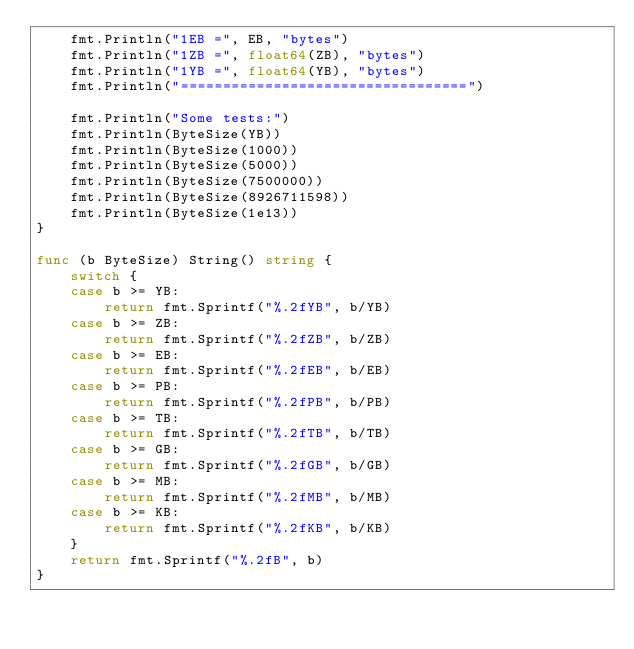<code> <loc_0><loc_0><loc_500><loc_500><_Go_>	fmt.Println("1EB =", EB, "bytes")
	fmt.Println("1ZB =", float64(ZB), "bytes")
	fmt.Println("1YB =", float64(YB), "bytes")
	fmt.Println("==================================")

	fmt.Println("Some tests:")
	fmt.Println(ByteSize(YB))
	fmt.Println(ByteSize(1000))
	fmt.Println(ByteSize(5000))
	fmt.Println(ByteSize(7500000))
	fmt.Println(ByteSize(8926711598))
	fmt.Println(ByteSize(1e13))
}

func (b ByteSize) String() string {
	switch {
	case b >= YB:
		return fmt.Sprintf("%.2fYB", b/YB)
	case b >= ZB:
		return fmt.Sprintf("%.2fZB", b/ZB)
	case b >= EB:
		return fmt.Sprintf("%.2fEB", b/EB)
	case b >= PB:
		return fmt.Sprintf("%.2fPB", b/PB)
	case b >= TB:
		return fmt.Sprintf("%.2fTB", b/TB)
	case b >= GB:
		return fmt.Sprintf("%.2fGB", b/GB)
	case b >= MB:
		return fmt.Sprintf("%.2fMB", b/MB)
	case b >= KB:
		return fmt.Sprintf("%.2fKB", b/KB)
	}
	return fmt.Sprintf("%.2fB", b)
}
</code> 